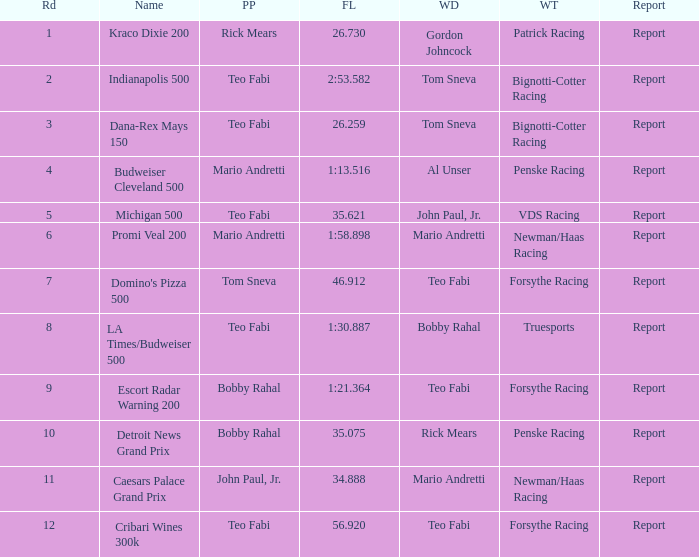What is the highest Rd that Tom Sneva had the pole position in? 7.0. Parse the table in full. {'header': ['Rd', 'Name', 'PP', 'FL', 'WD', 'WT', 'Report'], 'rows': [['1', 'Kraco Dixie 200', 'Rick Mears', '26.730', 'Gordon Johncock', 'Patrick Racing', 'Report'], ['2', 'Indianapolis 500', 'Teo Fabi', '2:53.582', 'Tom Sneva', 'Bignotti-Cotter Racing', 'Report'], ['3', 'Dana-Rex Mays 150', 'Teo Fabi', '26.259', 'Tom Sneva', 'Bignotti-Cotter Racing', 'Report'], ['4', 'Budweiser Cleveland 500', 'Mario Andretti', '1:13.516', 'Al Unser', 'Penske Racing', 'Report'], ['5', 'Michigan 500', 'Teo Fabi', '35.621', 'John Paul, Jr.', 'VDS Racing', 'Report'], ['6', 'Promi Veal 200', 'Mario Andretti', '1:58.898', 'Mario Andretti', 'Newman/Haas Racing', 'Report'], ['7', "Domino's Pizza 500", 'Tom Sneva', '46.912', 'Teo Fabi', 'Forsythe Racing', 'Report'], ['8', 'LA Times/Budweiser 500', 'Teo Fabi', '1:30.887', 'Bobby Rahal', 'Truesports', 'Report'], ['9', 'Escort Radar Warning 200', 'Bobby Rahal', '1:21.364', 'Teo Fabi', 'Forsythe Racing', 'Report'], ['10', 'Detroit News Grand Prix', 'Bobby Rahal', '35.075', 'Rick Mears', 'Penske Racing', 'Report'], ['11', 'Caesars Palace Grand Prix', 'John Paul, Jr.', '34.888', 'Mario Andretti', 'Newman/Haas Racing', 'Report'], ['12', 'Cribari Wines 300k', 'Teo Fabi', '56.920', 'Teo Fabi', 'Forsythe Racing', 'Report']]} 